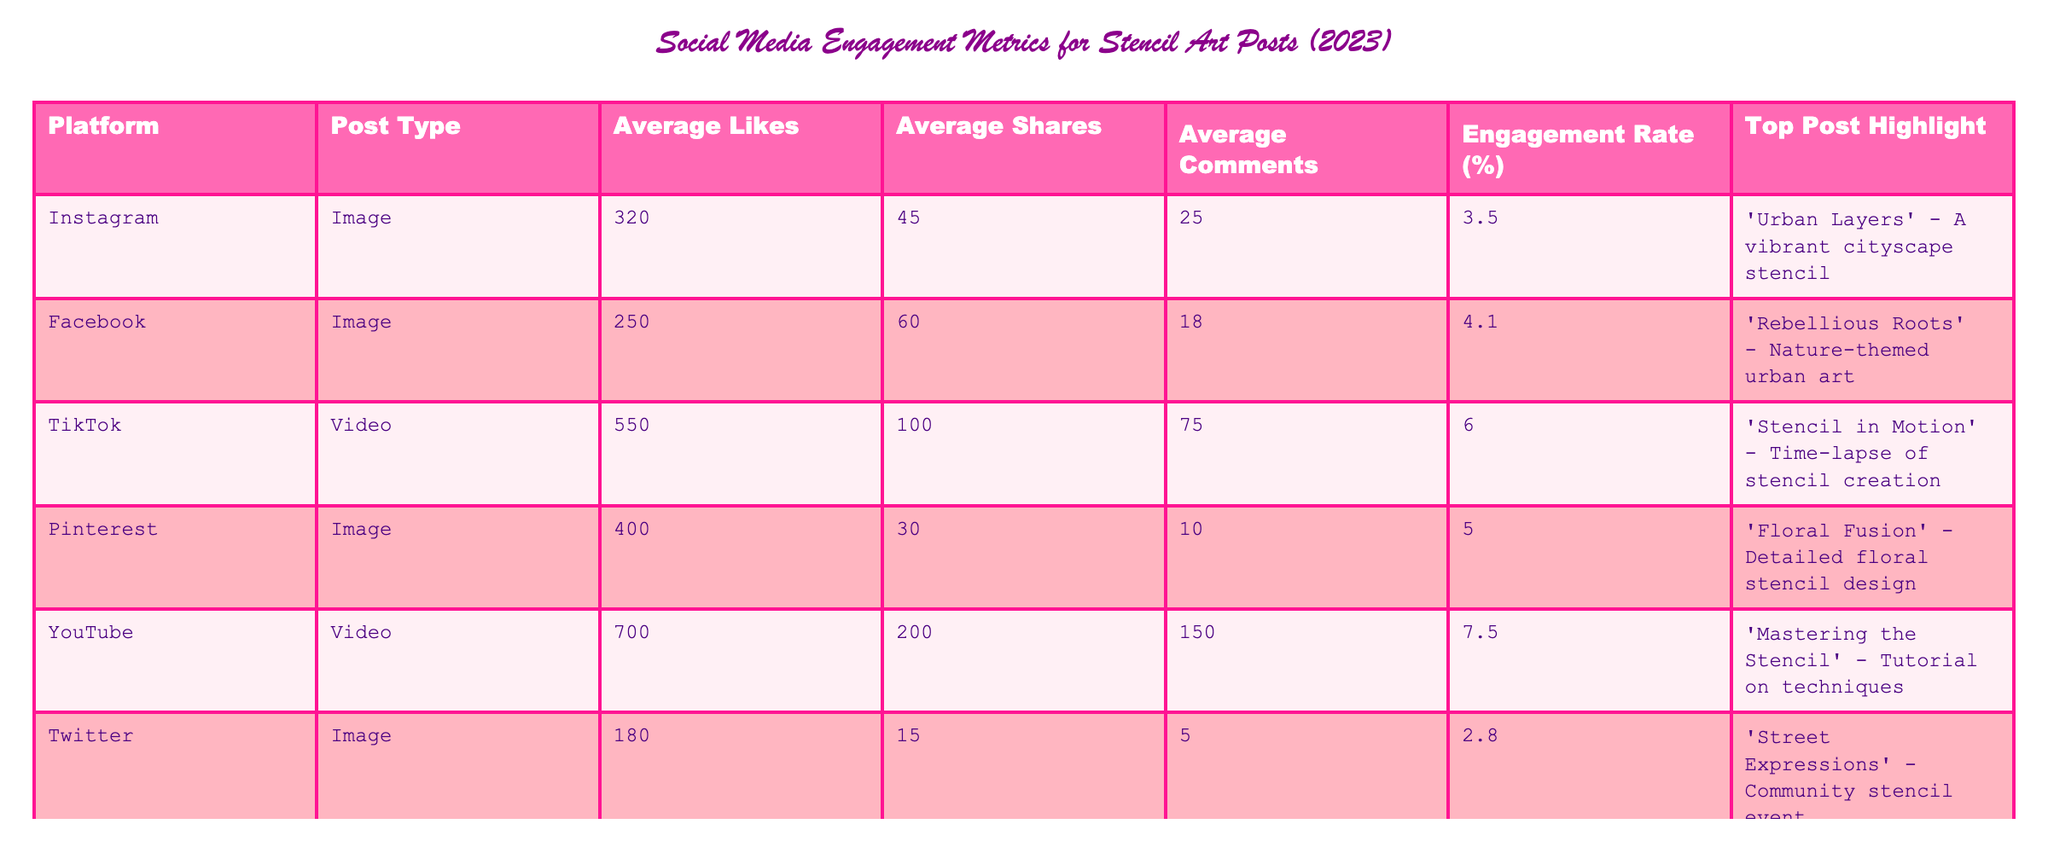What is the average engagement rate for TikTok posts? The table shows that the engagement rate for TikTok posts is 6.0%. This value is directly retrieved from the table without any calculations needed.
Answer: 6.0% Which platform had the most average likes for stencil art posts? According to the table, YouTube has the highest average likes at 700. This is the greatest numerical value in the "Average Likes" column.
Answer: YouTube What is the total number of average comments for all platforms? To find the total average comments, we need to add up the values for each platform: 25 + 18 + 75 + 10 + 150 + 5 + 20 = 303. Thus, the total is 303.
Answer: 303 Is the average number of shares for Twitter posts greater than that for Instagram posts? For Twitter, the average shares are 15, and for Instagram, it's 45. Since 15 is less than 45, the answer is no.
Answer: No What is the difference in average likes between YouTube and Twitter? The average likes for YouTube is 700, and for Twitter, it is 180. The difference is 700 - 180 = 520.
Answer: 520 Which platform has the least engagement rate, and what is that rate? Looking at the engagement rates, Twitter has the least at 2.8%, identified by comparing all rates in the table.
Answer: Twitter, 2.8% If we only consider image posts, what is the average engagement rate? The platforms with image posts are Instagram, Facebook, Pinterest, Twitter, and Reddit. Their engagement rates are 3.5%, 4.1%, 5.0%, 2.8%, and 4.5%. Calculating the average involves (3.5 + 4.1 + 5.0 + 2.8 + 4.5) / 5 = 4.18%.
Answer: 4.18% Which top post achieved the highest engagement rate, and what was that rate? The highest engagement rate is from YouTube, with 7.5%, being the maximum amongst all entries in the "Engagement Rate (%)" column.
Answer: YouTube, 7.5% How many more average shares do TikTok posts have compared to Pinterest posts? TikTok has an average of 100 shares while Pinterest has 30. The difference is 100 - 30 = 70.
Answer: 70 Do all platforms have an engagement rate higher than 4%? By examining the engagement rates, Twitter (2.8%) is lower than 4%, indicating not all platforms exceed this rate.
Answer: No 